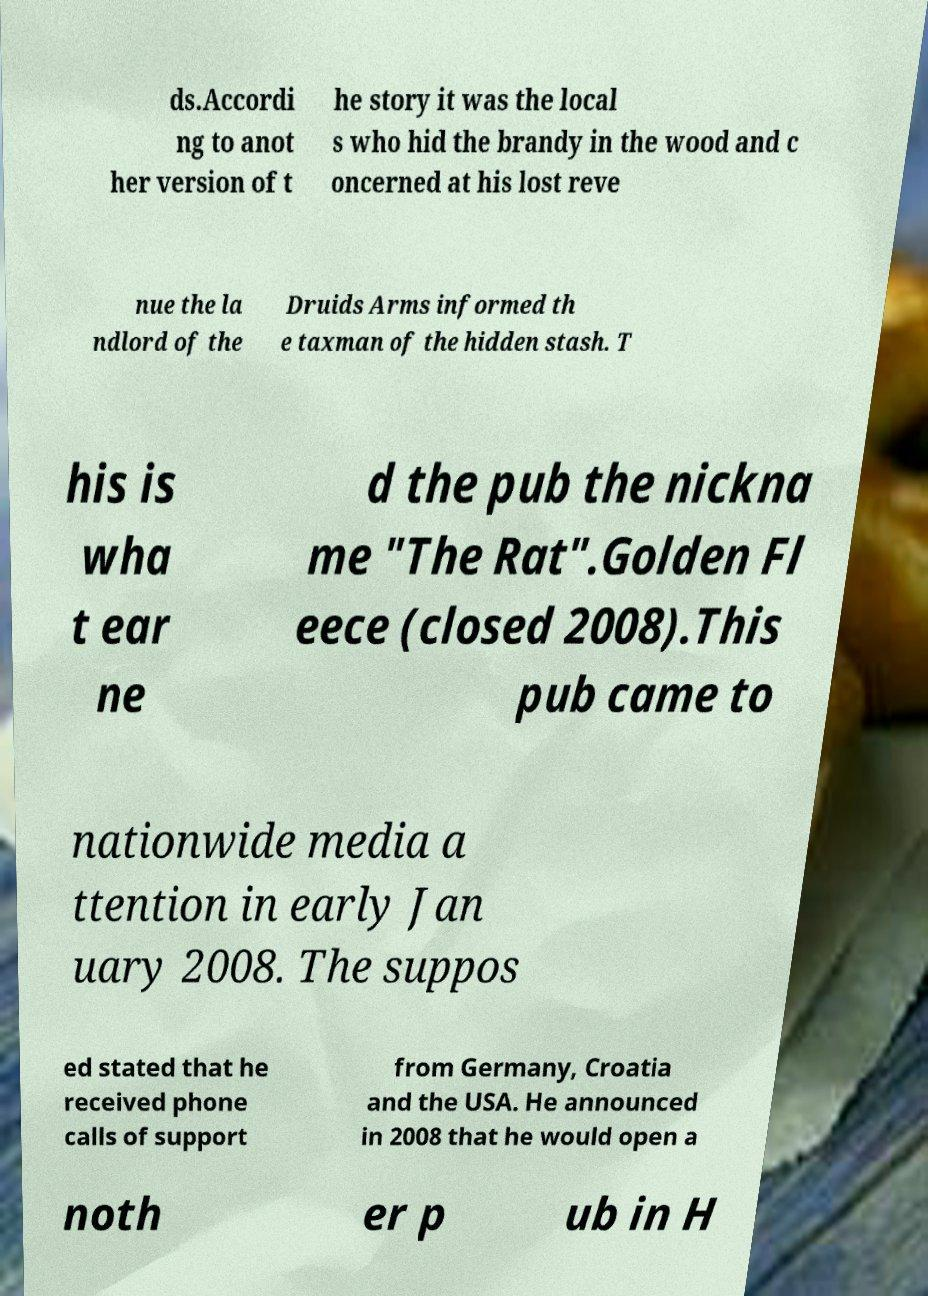For documentation purposes, I need the text within this image transcribed. Could you provide that? ds.Accordi ng to anot her version of t he story it was the local s who hid the brandy in the wood and c oncerned at his lost reve nue the la ndlord of the Druids Arms informed th e taxman of the hidden stash. T his is wha t ear ne d the pub the nickna me "The Rat".Golden Fl eece (closed 2008).This pub came to nationwide media a ttention in early Jan uary 2008. The suppos ed stated that he received phone calls of support from Germany, Croatia and the USA. He announced in 2008 that he would open a noth er p ub in H 